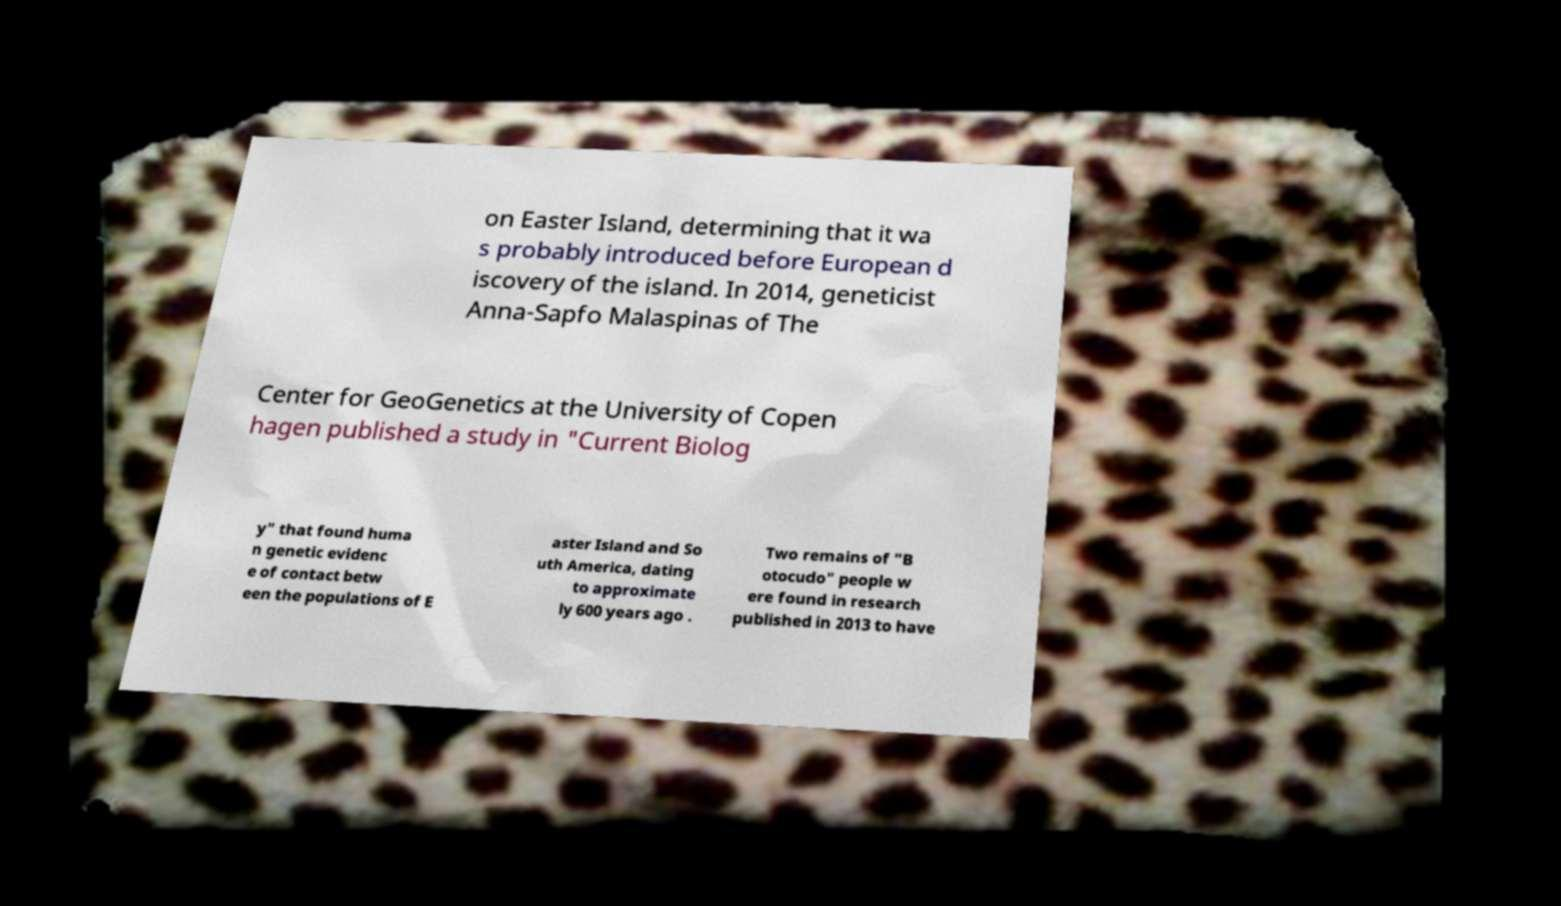I need the written content from this picture converted into text. Can you do that? on Easter Island, determining that it wa s probably introduced before European d iscovery of the island. In 2014, geneticist Anna-Sapfo Malaspinas of The Center for GeoGenetics at the University of Copen hagen published a study in "Current Biolog y" that found huma n genetic evidenc e of contact betw een the populations of E aster Island and So uth America, dating to approximate ly 600 years ago . Two remains of "B otocudo" people w ere found in research published in 2013 to have 